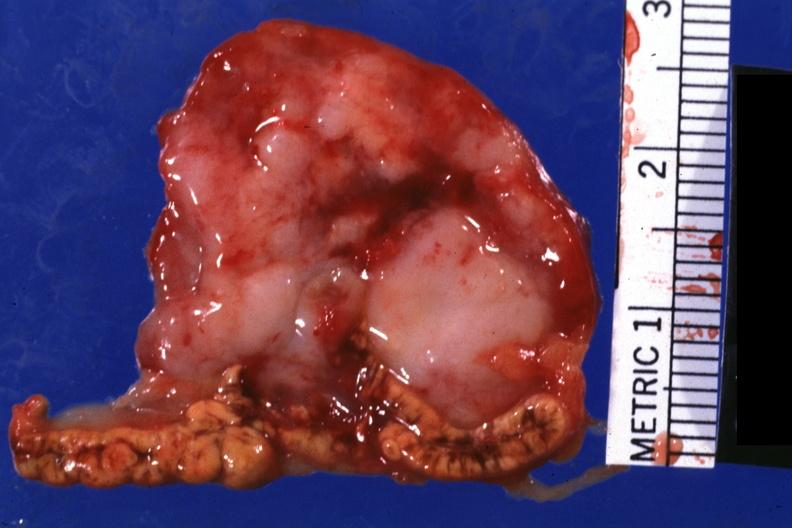s lateral view present?
Answer the question using a single word or phrase. No 